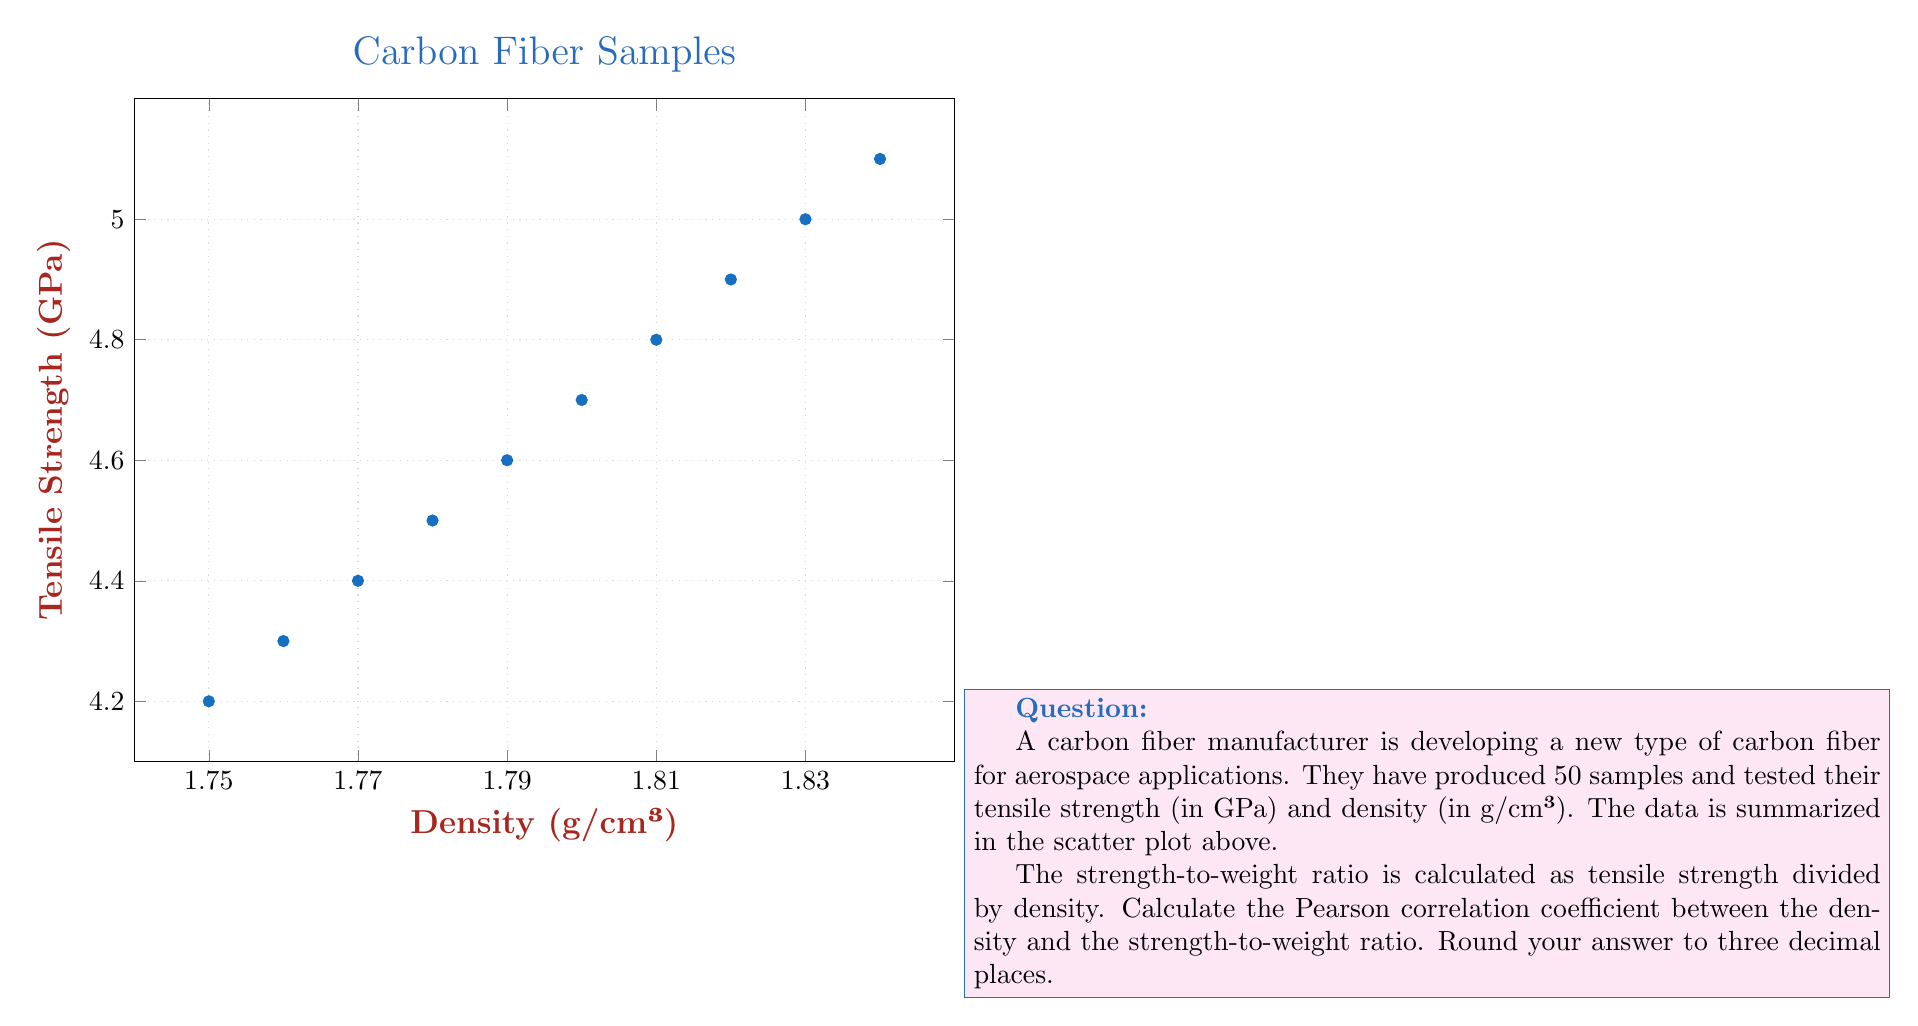Can you answer this question? To solve this problem, we'll follow these steps:

1) First, we need to calculate the strength-to-weight ratio for each data point.
   Strength-to-weight ratio = Tensile Strength / Density

2) Then, we'll calculate the Pearson correlation coefficient between density and the strength-to-weight ratio.

3) The formula for Pearson correlation coefficient is:

   $$r = \frac{\sum_{i=1}^{n} (x_i - \bar{x})(y_i - \bar{y})}{\sqrt{\sum_{i=1}^{n} (x_i - \bar{x})^2 \sum_{i=1}^{n} (y_i - \bar{y})^2}}$$

   where $x_i$ are the density values and $y_i$ are the strength-to-weight ratio values.

4) Let's calculate the strength-to-weight ratios:

   1.75: 4.2 / 1.75 = 2.400
   1.76: 4.3 / 1.76 = 2.443
   1.77: 4.4 / 1.77 = 2.486
   1.78: 4.5 / 1.78 = 2.528
   1.79: 4.6 / 1.79 = 2.570
   1.80: 4.7 / 1.80 = 2.611
   1.81: 4.8 / 1.81 = 2.652
   1.82: 4.9 / 1.82 = 2.692
   1.83: 5.0 / 1.83 = 2.732
   1.84: 5.1 / 1.84 = 2.772

5) Now we have our $x$ (density) and $y$ (strength-to-weight ratio) values.

6) Calculate the means:
   $\bar{x} = 1.795$
   $\bar{y} = 2.5886$

7) Calculate $(x_i - \bar{x})$, $(y_i - \bar{y})$, $(x_i - \bar{x})^2$, $(y_i - \bar{y})^2$, and $(x_i - \bar{x})(y_i - \bar{y})$ for each pair.

8) Sum up these values:
   $\sum (x_i - \bar{x})(y_i - \bar{y}) = 0.0495$
   $\sum (x_i - \bar{x})^2 = 0.0825$
   $\sum (y_i - \bar{y})^2 = 0.1386$

9) Plug these into the correlation formula:

   $$r = \frac{0.0495}{\sqrt{0.0825 * 0.1386}} = 0.4619$$

10) Rounding to three decimal places gives 0.462.
Answer: 0.462 